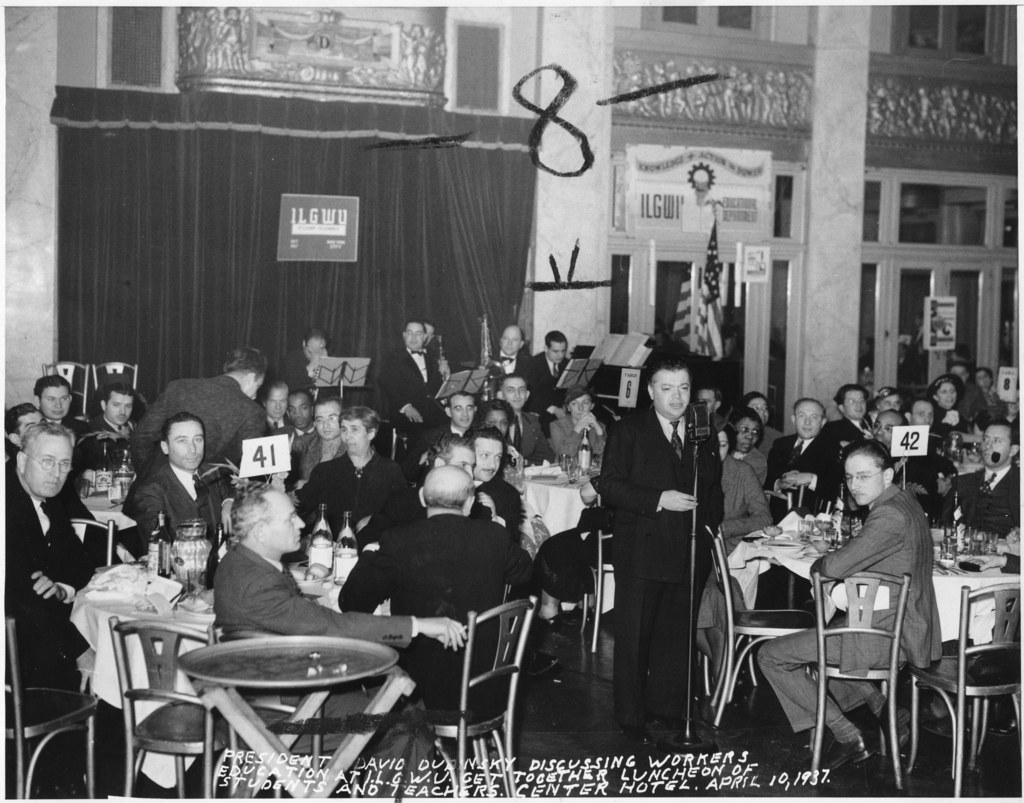Could you give a brief overview of what you see in this image? This is a black and white picture. Here we can see some persons are sitting on the chairs. These are the tables. On the table there are bottles, jars, and plates. This is floor. Here we can see a man who is talking on the mike. On the background there is a curtain and this is board. There is a door and this is pillar. 